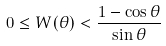Convert formula to latex. <formula><loc_0><loc_0><loc_500><loc_500>0 \leq W ( \theta ) < \frac { 1 - \cos \theta } { \sin \theta }</formula> 